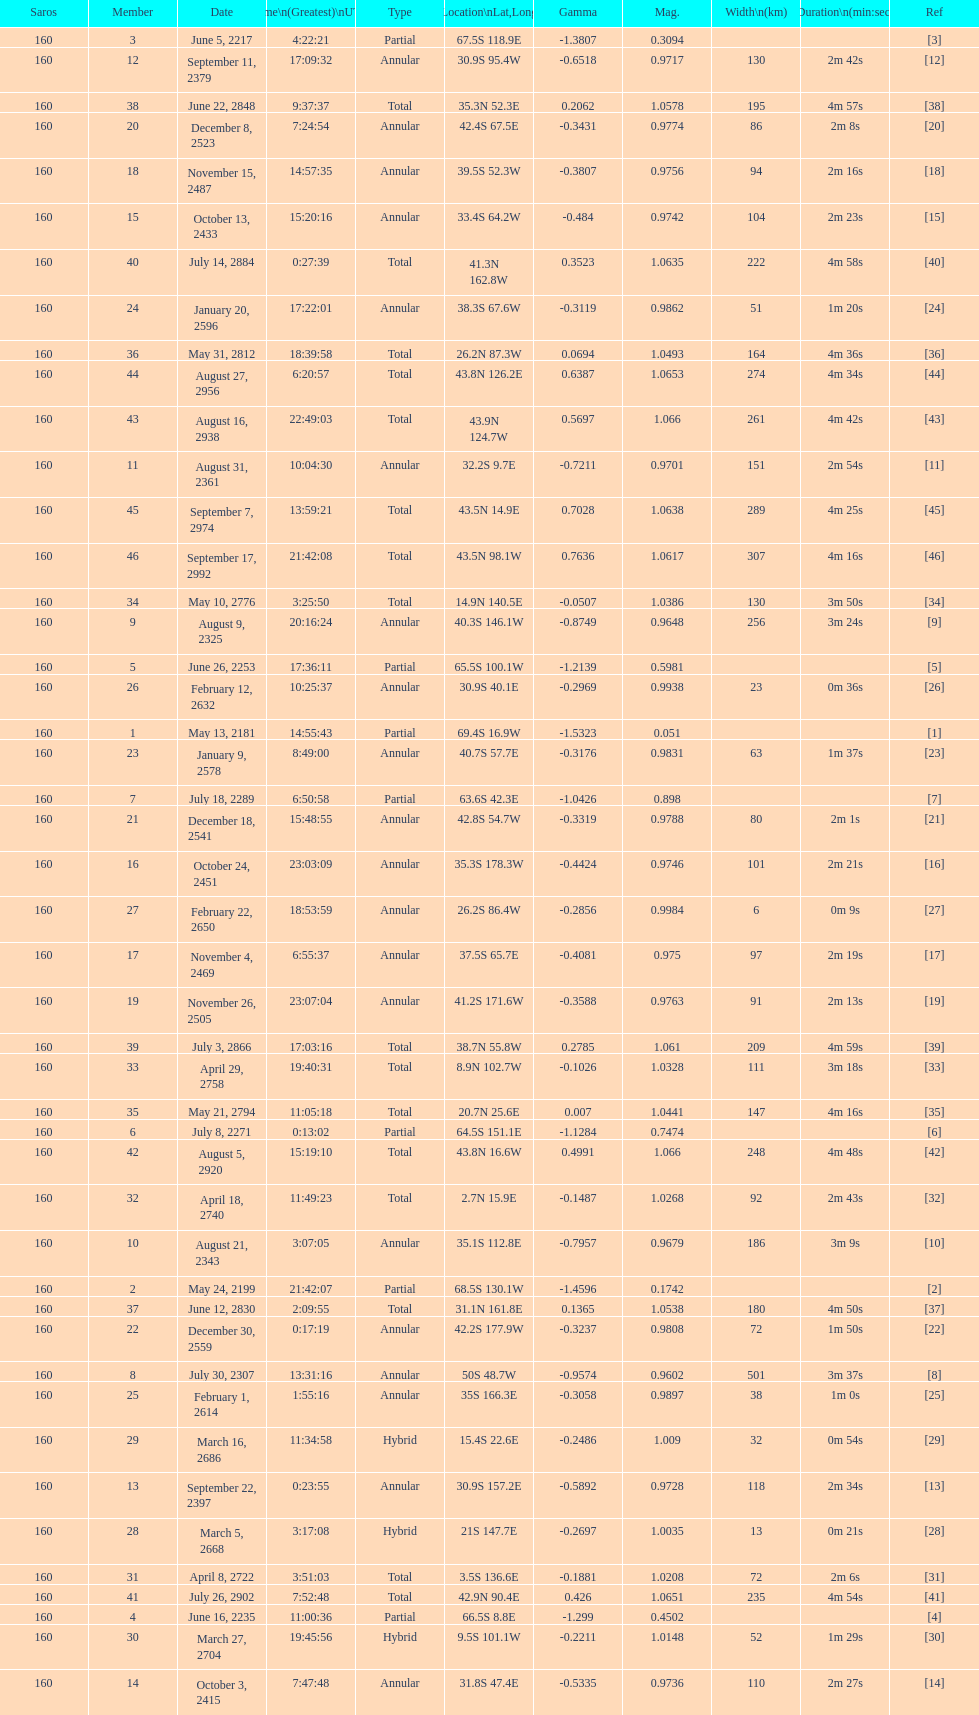When did the first solar saros with a magnitude of greater than 1.00 occur? March 5, 2668. 